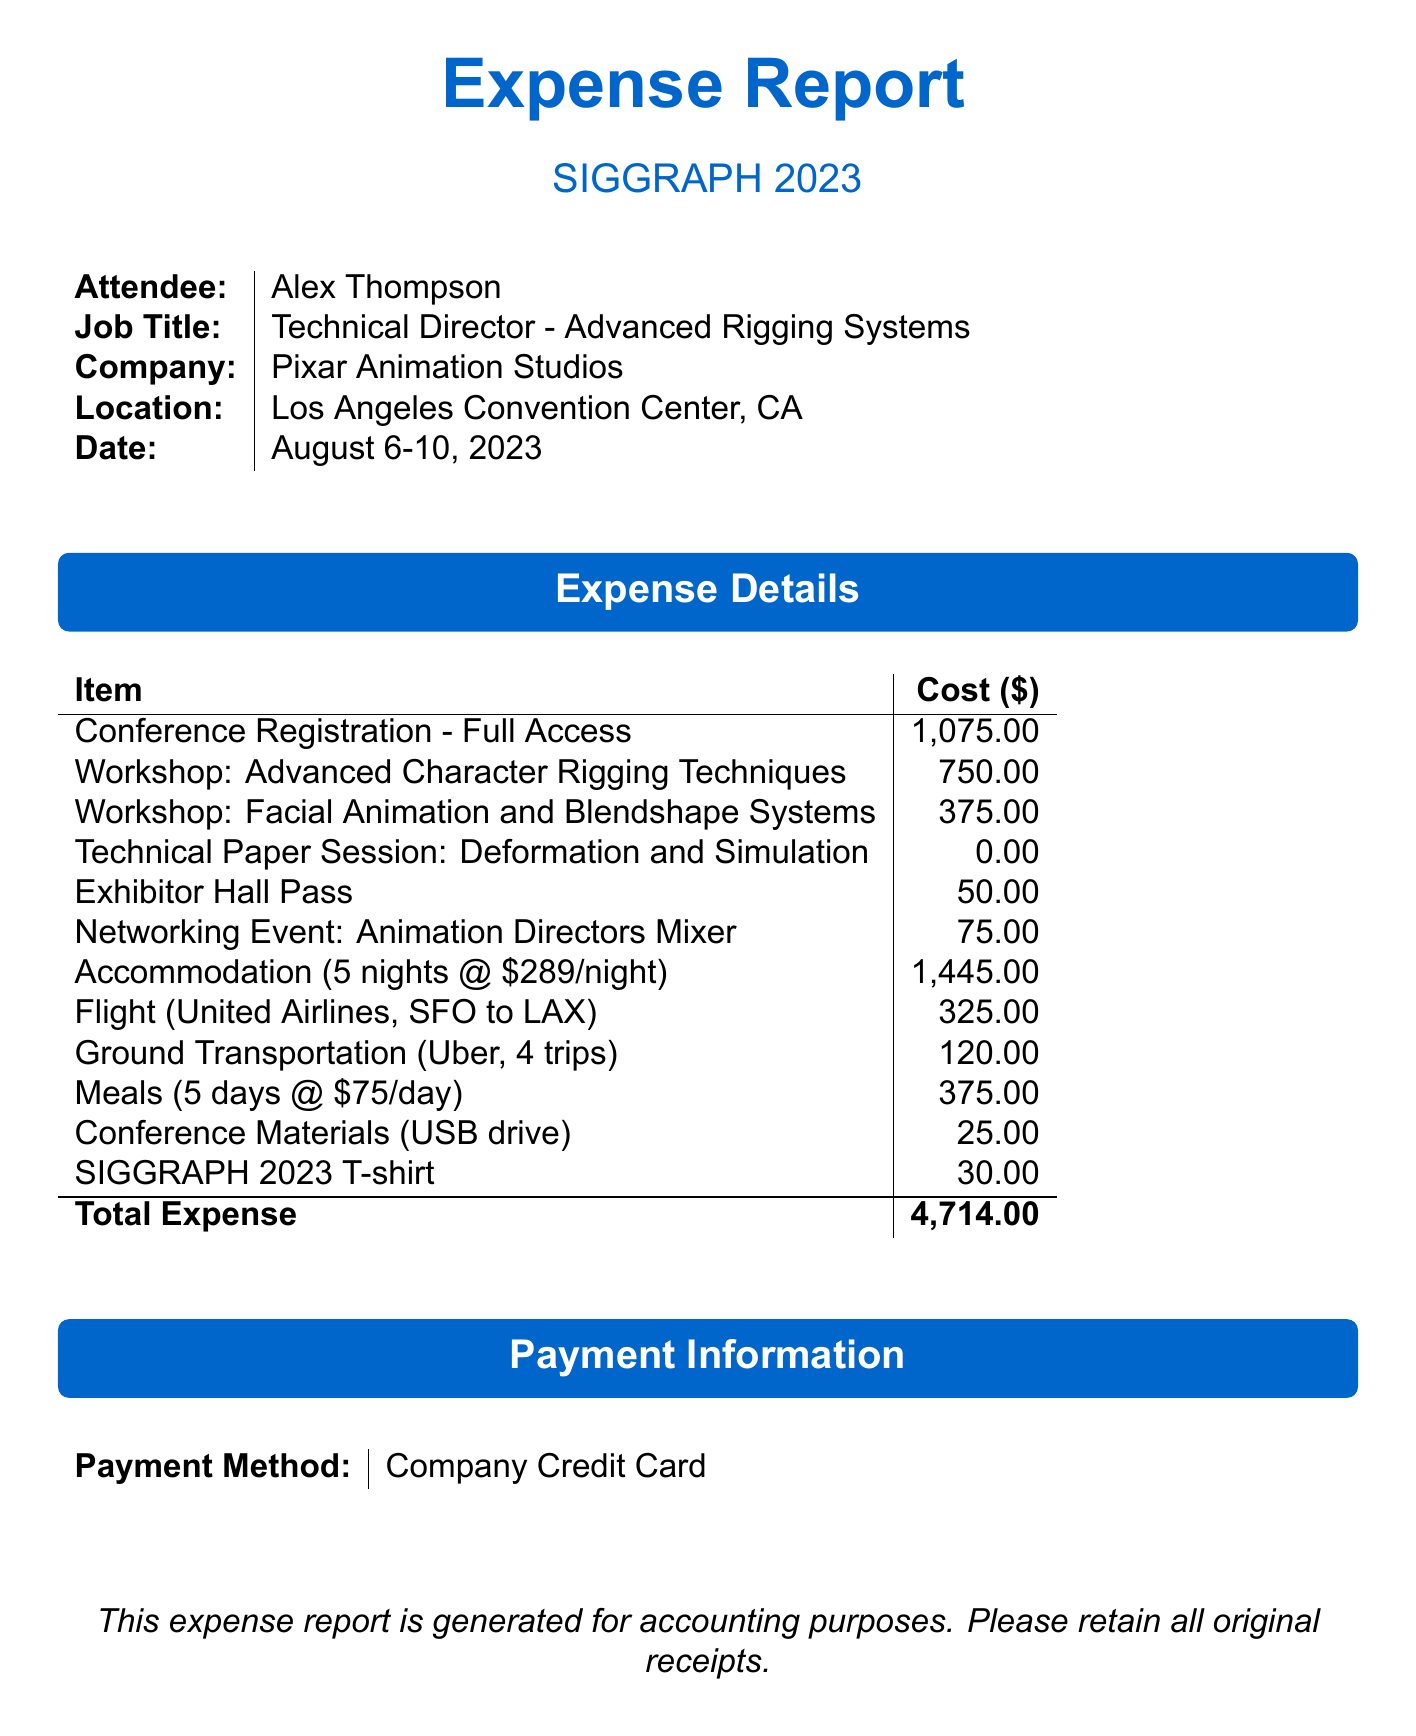What is the conference name? The conference name is clearly stated in the document.
Answer: SIGGRAPH 2023 How many nights did Alex stay at the hotel? The number of nights is specified in the accommodation section of the document.
Answer: 5 What is the cost of the workshop on Advanced Character Rigging Techniques? The cost for this workshop is provided in the expense details.
Answer: 750.00 What is the total expense reported? The total expense is the sum of all expenses listed in the document.
Answer: 4714.00 Who was the instructor for the Facial Animation workshop? The instructor's name is provided alongside the workshop in the expense details.
Answer: Sze Chan What was the cost of the flight from San Francisco to Los Angeles? The flight cost is mentioned in the transportation section of the document.
Answer: 325.00 What payment method was used for the expenses? The payment information is provided at the end of the document.
Answer: Company Credit Card What type of event was the Animation Directors Mixer? The event is specified in the expense details, indicating its purpose.
Answer: Networking Event How much was spent on meals per day? The meals expense details include a per diem amount.
Answer: 75.00 